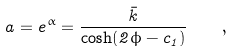Convert formula to latex. <formula><loc_0><loc_0><loc_500><loc_500>a = e ^ { \alpha } = \frac { \bar { k } } { \cosh ( 2 \phi - c _ { 1 } ) } \quad ,</formula> 